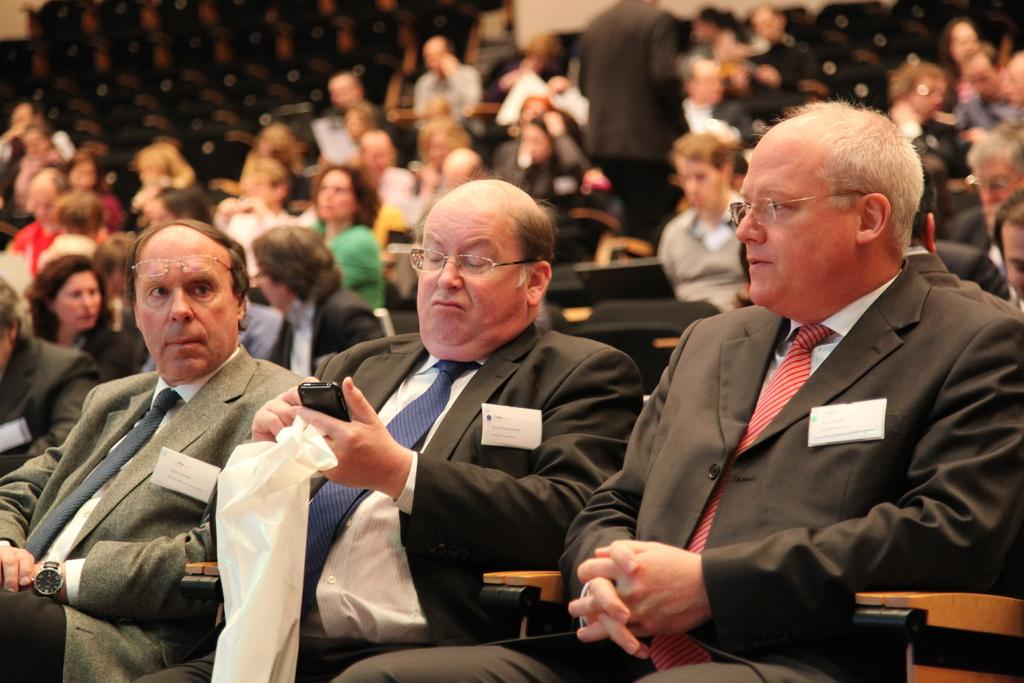What is the main setting of the image? The main setting of the image is an auditorium. How are the people in the image positioned? Many people are sitting in the auditorium. What are the three men wearing? The three men are wearing blazers, ties, and shirts. What is one man holding in the image? One man is holding a cloth. What type of harmony is being played by the people in the image? There is no indication of music or harmony being played in the image; it features people sitting in an auditorium. Can you tell me where the sink is located in the image? There is no sink present in the image. 